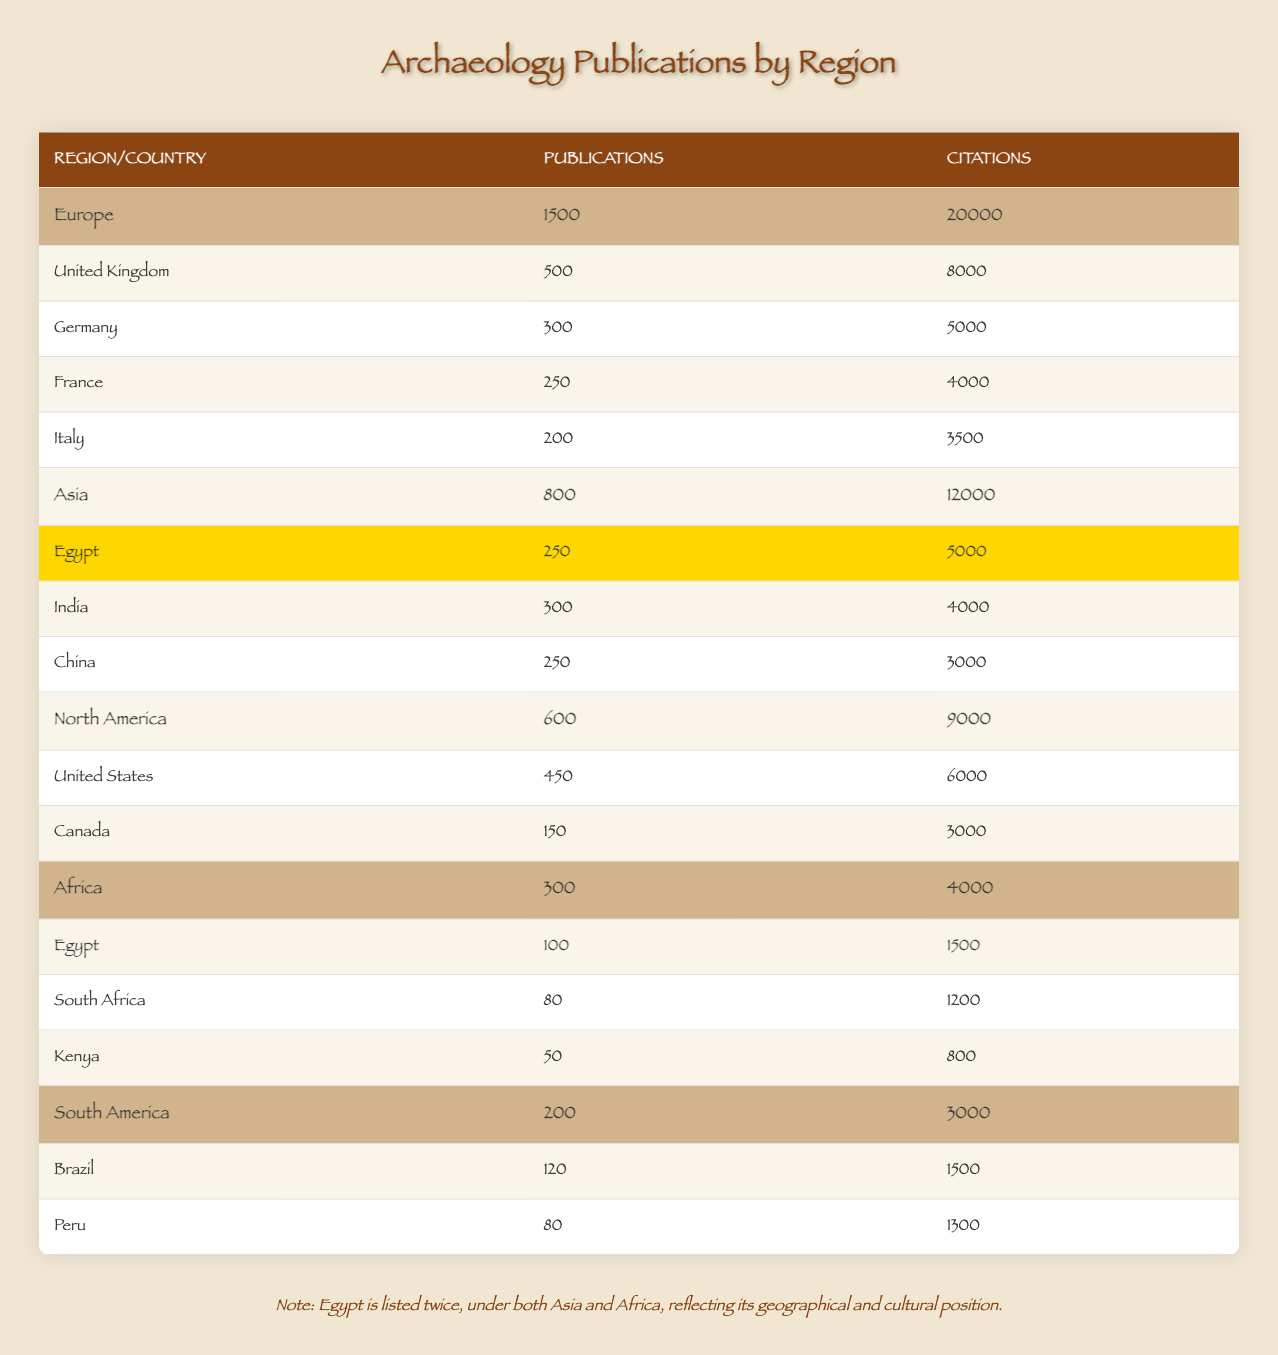What is the total number of publications in Europe? According to the table, Europe has a total of 1500 publications listed.
Answer: 1500 Which region has the highest number of citations? The total citations for each region are as follows: Europe (20000), Asia (12000), North America (9000), Africa (4000), and South America (3000). Therefore, Europe has the highest number of citations.
Answer: Europe What is the total number of publications from Egypt across both regions? Egypt has 250 publications in Asia and 100 publications in Africa. Adding these together gives 250 + 100 = 350 publications.
Answer: 350 How many more citations does the United Kingdom have compared to Germany? The United Kingdom has 8000 citations, while Germany has 5000 citations. The difference is calculated as 8000 - 5000 = 3000 citations.
Answer: 3000 Is it true that the total number of publications in North America is less than that in Asia? In the table, North America has 600 publications, while Asia has 800 publications. Since 600 is less than 800, the statement is true.
Answer: Yes What is the average number of publications per country in South America? There are 2 countries (Brazil and Peru) in South America with a total of 200 publications. The average is calculated as 200 publications / 2 countries = 100 publications per country.
Answer: 100 Which country has the highest citations in Asia? From the table, Egypt has 5000 citations, India has 4000 citations, and China has 3000 citations. Since 5000 is greater than both 4000 and 3000, Egypt has the highest citations in Asia.
Answer: Egypt If we consider only the African countries listed, which country contributes the least to the total citations? Egypt provides 1500 citations, South Africa contributes 1200 citations, and Kenya adds 800 citations. Out of these, Kenya has the least with 800 citations.
Answer: Kenya How many publications are there in total in Africa? The total publications in Africa are the sum of publications from Egypt (100), South Africa (80), and Kenya (50), which is calculated as 100 + 80 + 50 = 230 publications.
Answer: 230 